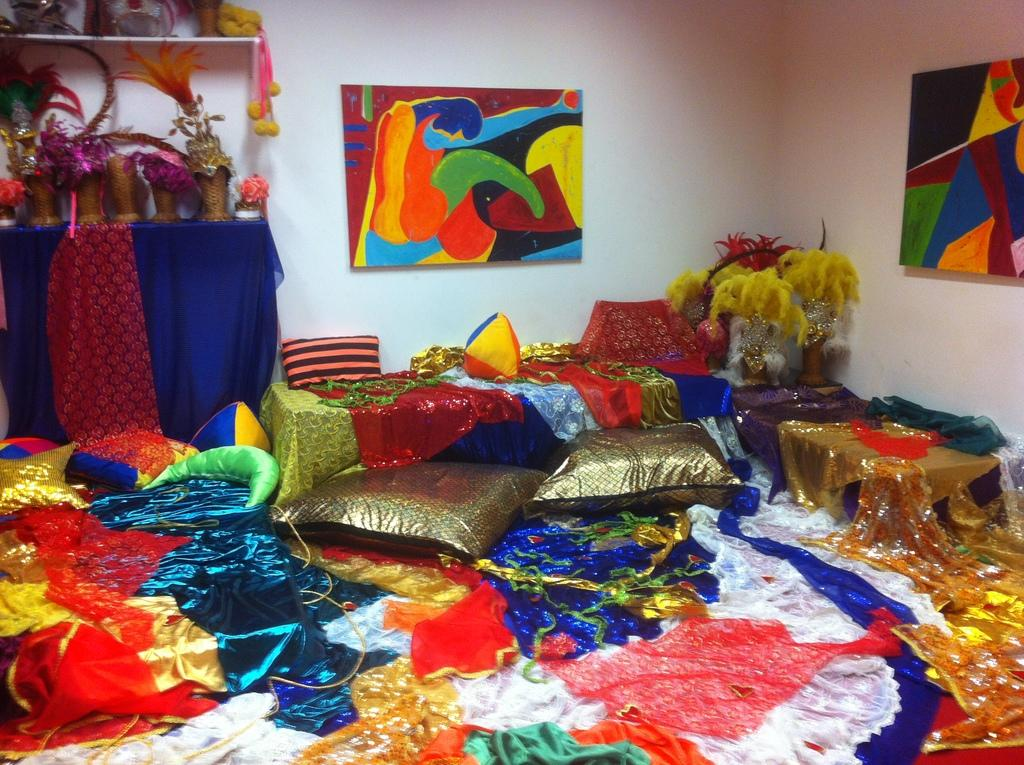What type of soft furnishings can be seen in the image? There are pillows in the image. What type of items are visible that might be worn? There are colorful clothes in the image. What can be seen on the wall in the image? There are photo frames on the wall in the image. What is placed on the table in the image? There are objects placed on a table in the image. How many passengers are visible in the image? There are no passengers present in the image. What type of fruit is placed on the table in the image? There is no fruit visible on the table in the image. 